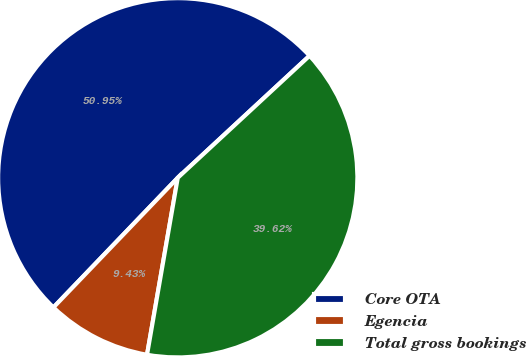Convert chart. <chart><loc_0><loc_0><loc_500><loc_500><pie_chart><fcel>Core OTA<fcel>Egencia<fcel>Total gross bookings<nl><fcel>50.94%<fcel>9.43%<fcel>39.62%<nl></chart> 